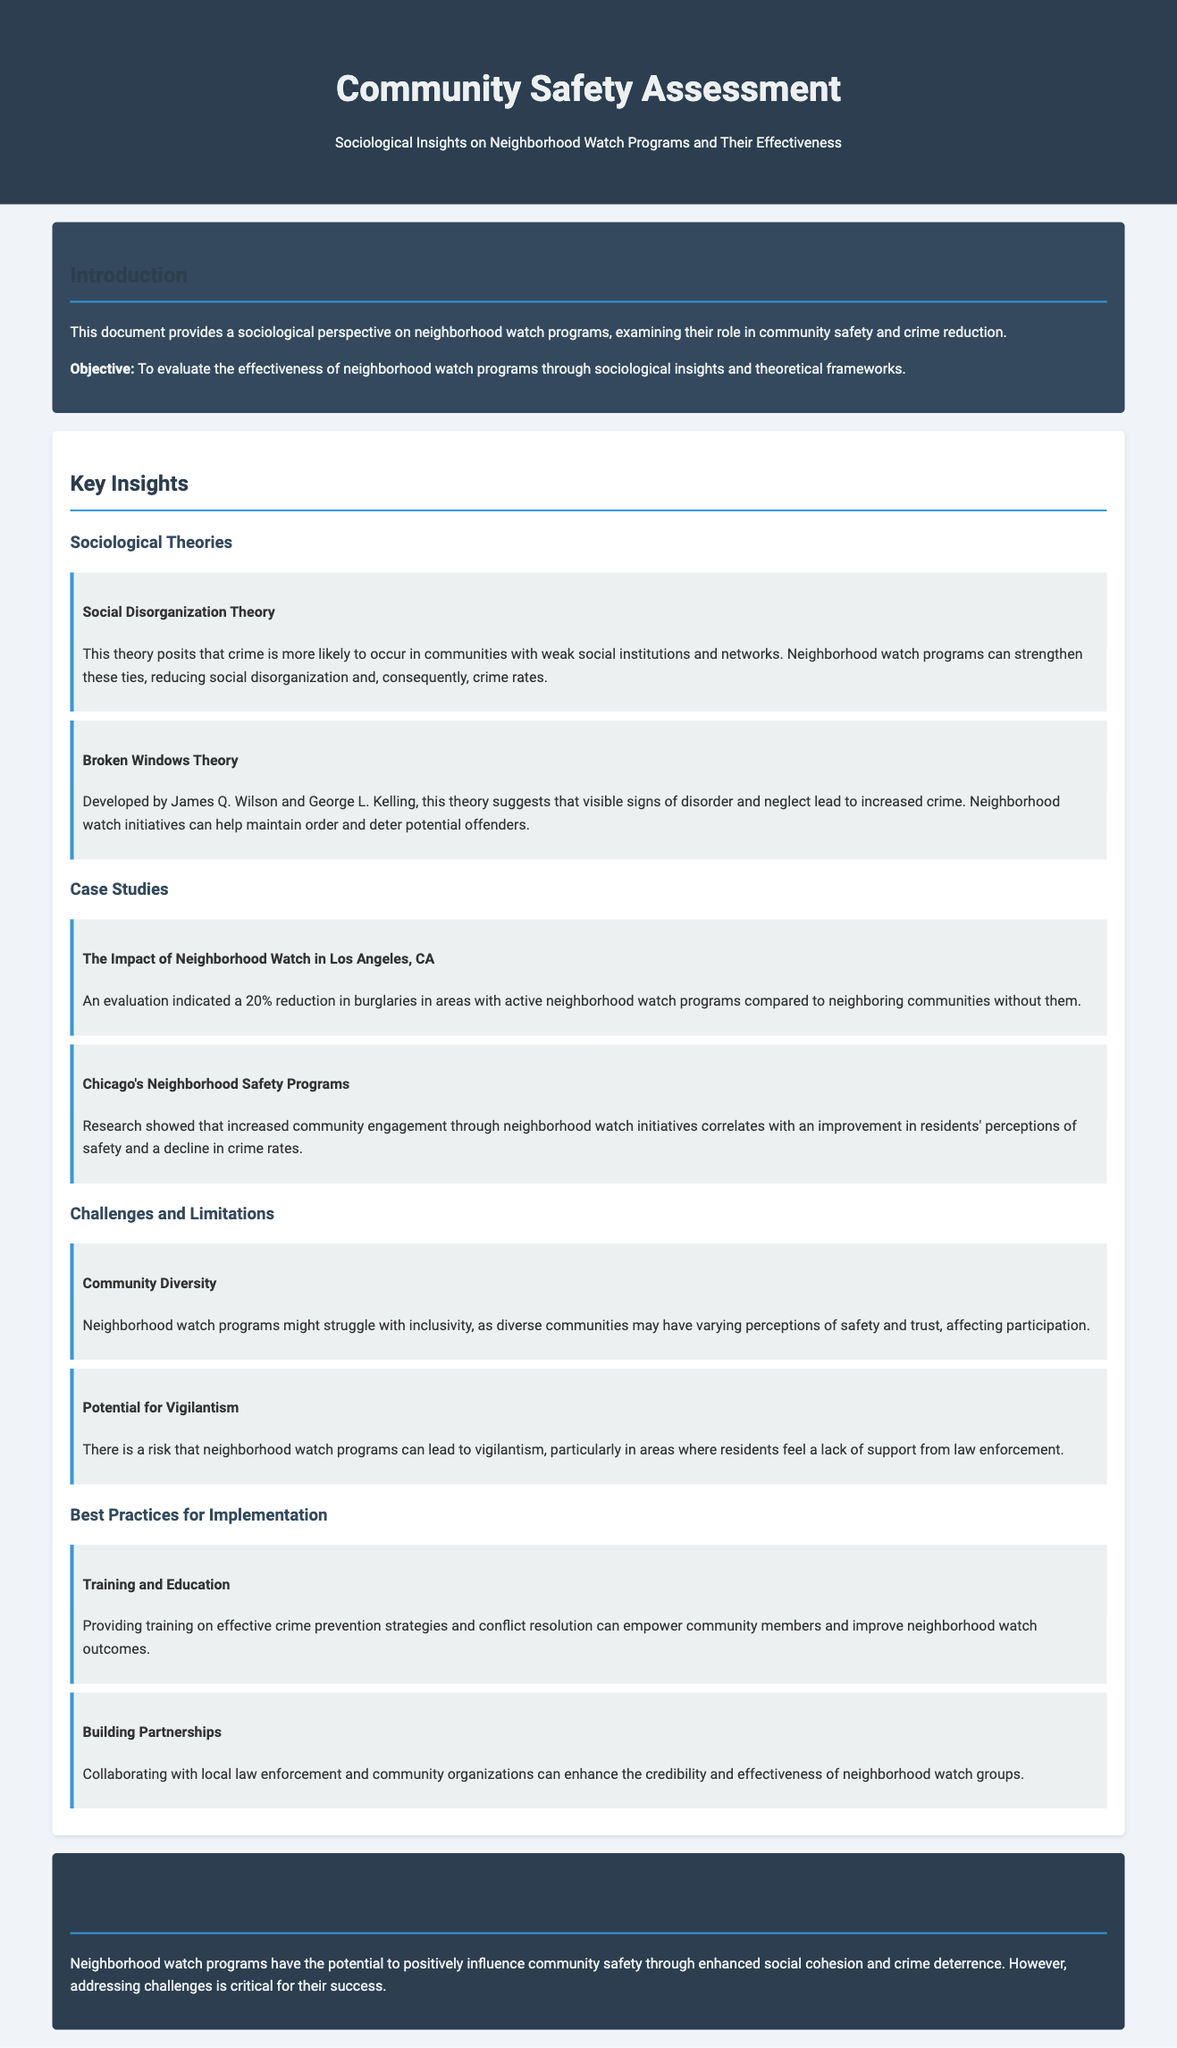What is the main objective of the document? The objective is to evaluate the effectiveness of neighborhood watch programs through sociological insights and theoretical frameworks.
Answer: To evaluate the effectiveness of neighborhood watch programs What is the reduction percentage of burglaries in Los Angeles? An evaluation indicated a 20% reduction in burglaries in areas with active neighborhood watch programs.
Answer: 20% Which theory suggests that visible signs of disorder lead to increased crime? This theory suggests that visible signs of disorder lead to increased crime and is known as the Broken Windows Theory.
Answer: Broken Windows Theory What challenge is associated with community diversity in neighborhood watch programs? Neighborhood watch programs might struggle with inclusivity due to varying perceptions of safety among diverse communities.
Answer: Inclusivity What is one best practice for neighborhood watch implementation? Providing training on effective crime prevention strategies can empower community members.
Answer: Training and Education 